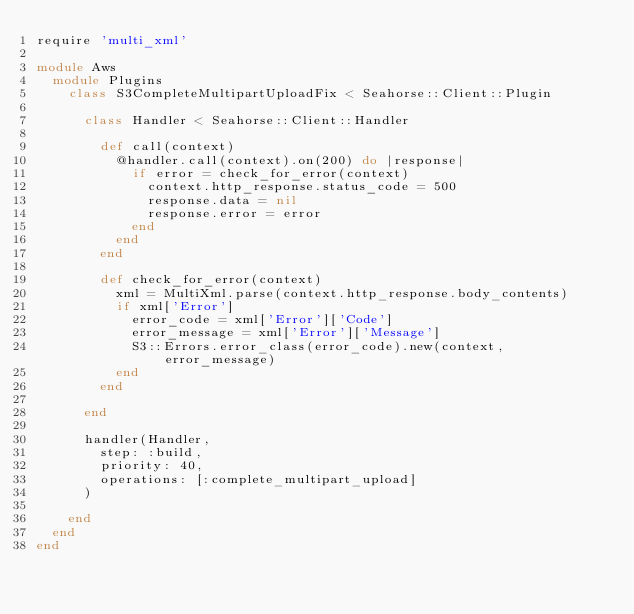<code> <loc_0><loc_0><loc_500><loc_500><_Ruby_>require 'multi_xml'

module Aws
  module Plugins
    class S3CompleteMultipartUploadFix < Seahorse::Client::Plugin

      class Handler < Seahorse::Client::Handler

        def call(context)
          @handler.call(context).on(200) do |response|
            if error = check_for_error(context)
              context.http_response.status_code = 500
              response.data = nil
              response.error = error
            end
          end
        end

        def check_for_error(context)
          xml = MultiXml.parse(context.http_response.body_contents)
          if xml['Error']
            error_code = xml['Error']['Code']
            error_message = xml['Error']['Message']
            S3::Errors.error_class(error_code).new(context, error_message)
          end
        end

      end

      handler(Handler,
        step: :build,
        priority: 40,
        operations: [:complete_multipart_upload]
      )

    end
  end
end
</code> 